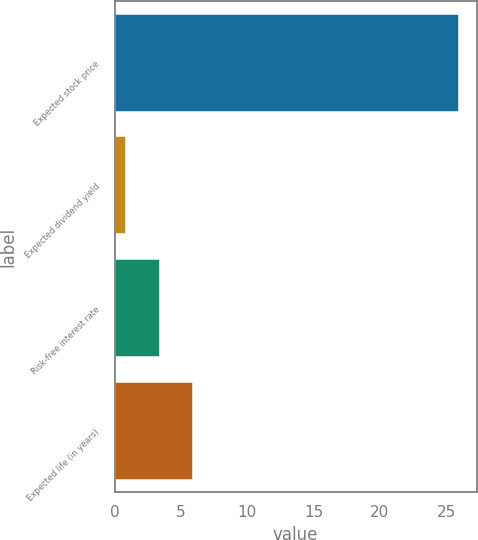Convert chart. <chart><loc_0><loc_0><loc_500><loc_500><bar_chart><fcel>Expected stock price<fcel>Expected dividend yield<fcel>Risk-free interest rate<fcel>Expected life (in years)<nl><fcel>26<fcel>0.9<fcel>3.41<fcel>5.92<nl></chart> 